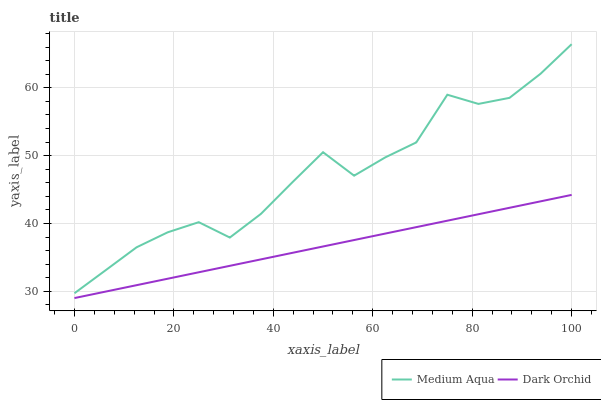Does Dark Orchid have the minimum area under the curve?
Answer yes or no. Yes. Does Medium Aqua have the maximum area under the curve?
Answer yes or no. Yes. Does Dark Orchid have the maximum area under the curve?
Answer yes or no. No. Is Dark Orchid the smoothest?
Answer yes or no. Yes. Is Medium Aqua the roughest?
Answer yes or no. Yes. Is Dark Orchid the roughest?
Answer yes or no. No. Does Dark Orchid have the lowest value?
Answer yes or no. Yes. Does Medium Aqua have the highest value?
Answer yes or no. Yes. Does Dark Orchid have the highest value?
Answer yes or no. No. Is Dark Orchid less than Medium Aqua?
Answer yes or no. Yes. Is Medium Aqua greater than Dark Orchid?
Answer yes or no. Yes. Does Dark Orchid intersect Medium Aqua?
Answer yes or no. No. 